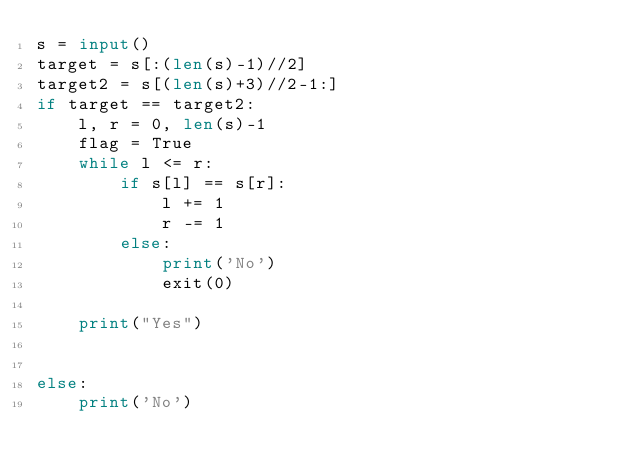<code> <loc_0><loc_0><loc_500><loc_500><_Python_>s = input()
target = s[:(len(s)-1)//2]
target2 = s[(len(s)+3)//2-1:]
if target == target2:
    l, r = 0, len(s)-1
    flag = True
    while l <= r:
        if s[l] == s[r]:
            l += 1
            r -= 1
        else:
            print('No')
            exit(0)

    print("Yes")


else:
    print('No')
</code> 